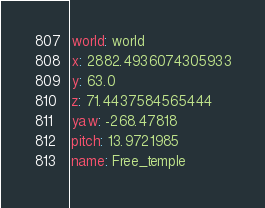<code> <loc_0><loc_0><loc_500><loc_500><_YAML_>world: world
x: 2882.4936074305933
y: 63.0
z: 71.4437584565444
yaw: -268.47818
pitch: 13.9721985
name: Free_temple
</code> 